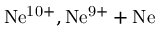Convert formula to latex. <formula><loc_0><loc_0><loc_500><loc_500>N e ^ { 1 0 + } , N e ^ { 9 + } + N e</formula> 